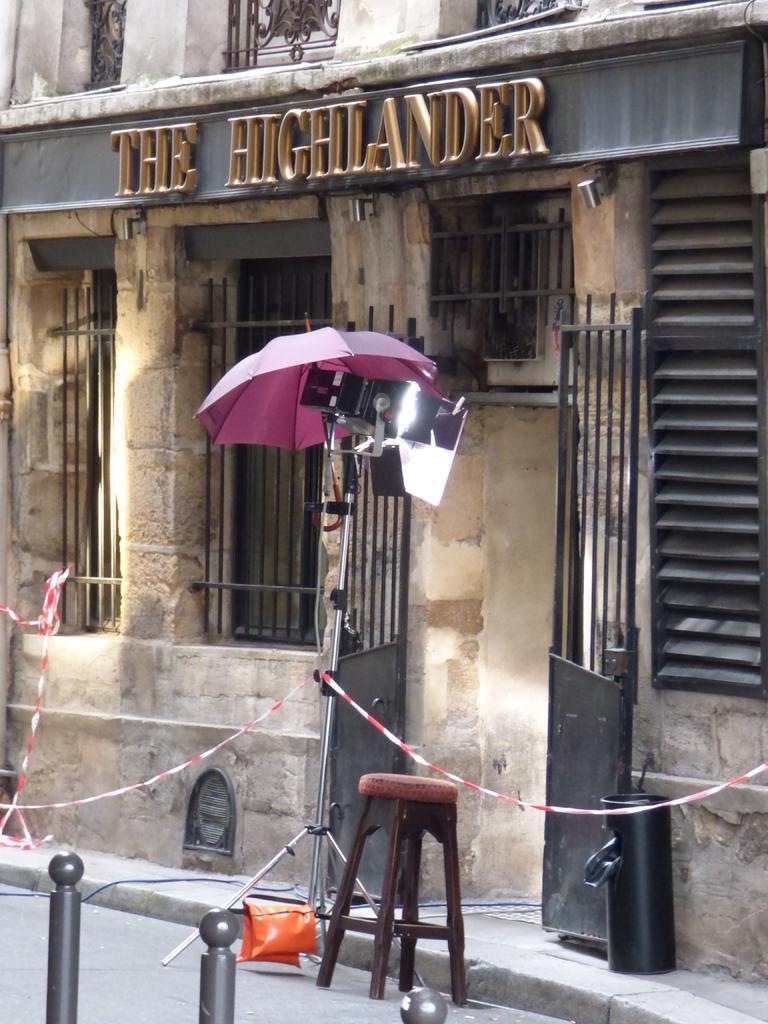Describe this image in one or two sentences. On the left side, there are poles. On the right side, there is a footpath, on which there is a dustbin. Beside this footpath, there is a stool on the road. Beside this stool, there is an umbrella attached to a stand. Beside this stand, there is a building which is having windows, a hoarding on the wall and a gate. 